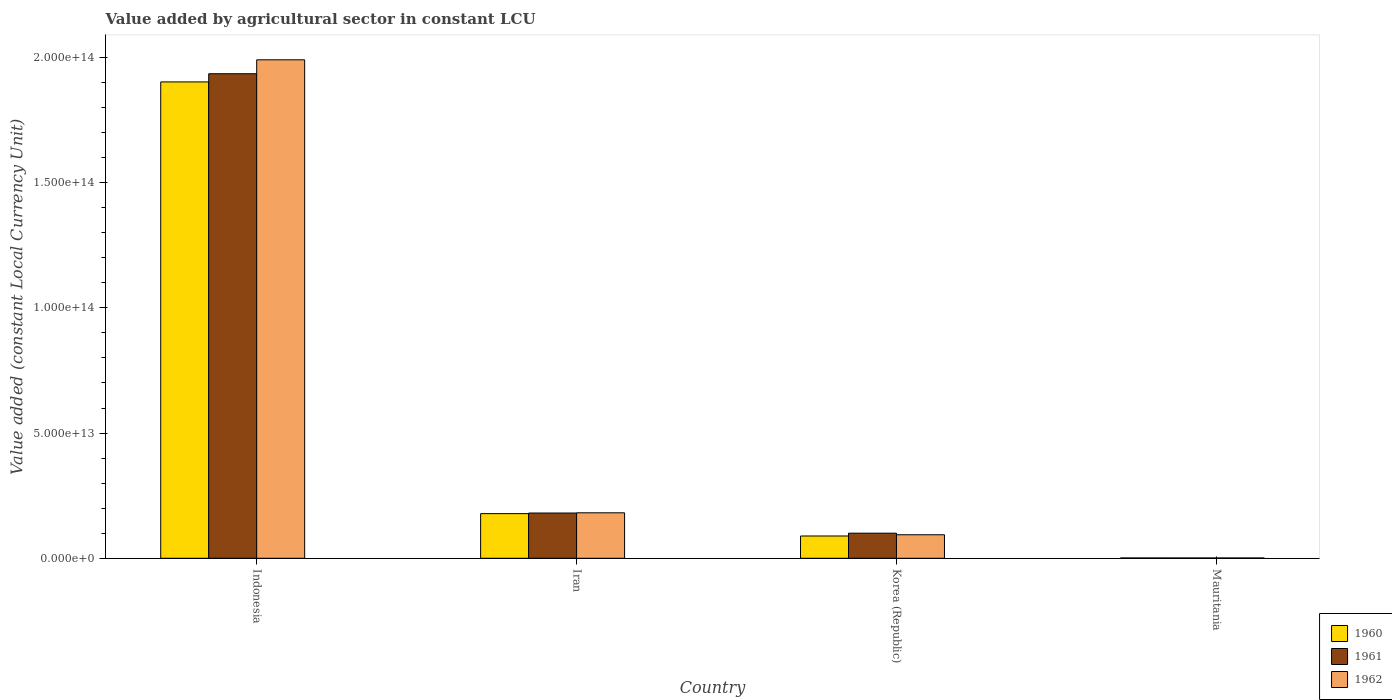How many different coloured bars are there?
Your answer should be very brief. 3. How many groups of bars are there?
Your response must be concise. 4. What is the label of the 4th group of bars from the left?
Your answer should be very brief. Mauritania. What is the value added by agricultural sector in 1961 in Indonesia?
Make the answer very short. 1.94e+14. Across all countries, what is the maximum value added by agricultural sector in 1962?
Keep it short and to the point. 1.99e+14. Across all countries, what is the minimum value added by agricultural sector in 1961?
Keep it short and to the point. 1.23e+11. In which country was the value added by agricultural sector in 1962 maximum?
Offer a very short reply. Indonesia. In which country was the value added by agricultural sector in 1960 minimum?
Offer a terse response. Mauritania. What is the total value added by agricultural sector in 1961 in the graph?
Your answer should be very brief. 2.22e+14. What is the difference between the value added by agricultural sector in 1961 in Iran and that in Mauritania?
Make the answer very short. 1.79e+13. What is the difference between the value added by agricultural sector in 1962 in Indonesia and the value added by agricultural sector in 1960 in Mauritania?
Your answer should be very brief. 1.99e+14. What is the average value added by agricultural sector in 1962 per country?
Offer a very short reply. 5.67e+13. What is the difference between the value added by agricultural sector of/in 1962 and value added by agricultural sector of/in 1960 in Iran?
Give a very brief answer. 3.32e+11. In how many countries, is the value added by agricultural sector in 1962 greater than 90000000000000 LCU?
Make the answer very short. 1. What is the ratio of the value added by agricultural sector in 1961 in Korea (Republic) to that in Mauritania?
Your response must be concise. 81.29. Is the value added by agricultural sector in 1961 in Indonesia less than that in Mauritania?
Make the answer very short. No. What is the difference between the highest and the second highest value added by agricultural sector in 1962?
Make the answer very short. -8.77e+12. What is the difference between the highest and the lowest value added by agricultural sector in 1960?
Your answer should be very brief. 1.90e+14. Is the sum of the value added by agricultural sector in 1960 in Korea (Republic) and Mauritania greater than the maximum value added by agricultural sector in 1962 across all countries?
Your response must be concise. No. What does the 2nd bar from the left in Iran represents?
Keep it short and to the point. 1961. How many bars are there?
Your answer should be compact. 12. Are all the bars in the graph horizontal?
Provide a succinct answer. No. How many countries are there in the graph?
Offer a very short reply. 4. What is the difference between two consecutive major ticks on the Y-axis?
Give a very brief answer. 5.00e+13. Does the graph contain any zero values?
Your answer should be compact. No. Does the graph contain grids?
Ensure brevity in your answer.  No. What is the title of the graph?
Provide a short and direct response. Value added by agricultural sector in constant LCU. What is the label or title of the X-axis?
Ensure brevity in your answer.  Country. What is the label or title of the Y-axis?
Your answer should be compact. Value added (constant Local Currency Unit). What is the Value added (constant Local Currency Unit) in 1960 in Indonesia?
Provide a succinct answer. 1.90e+14. What is the Value added (constant Local Currency Unit) in 1961 in Indonesia?
Keep it short and to the point. 1.94e+14. What is the Value added (constant Local Currency Unit) of 1962 in Indonesia?
Offer a very short reply. 1.99e+14. What is the Value added (constant Local Currency Unit) of 1960 in Iran?
Your answer should be very brief. 1.78e+13. What is the Value added (constant Local Currency Unit) of 1961 in Iran?
Your answer should be very brief. 1.81e+13. What is the Value added (constant Local Currency Unit) in 1962 in Iran?
Your response must be concise. 1.82e+13. What is the Value added (constant Local Currency Unit) in 1960 in Korea (Republic)?
Keep it short and to the point. 8.90e+12. What is the Value added (constant Local Currency Unit) in 1961 in Korea (Republic)?
Provide a short and direct response. 1.00e+13. What is the Value added (constant Local Currency Unit) of 1962 in Korea (Republic)?
Your answer should be very brief. 9.39e+12. What is the Value added (constant Local Currency Unit) in 1960 in Mauritania?
Your answer should be very brief. 1.27e+11. What is the Value added (constant Local Currency Unit) of 1961 in Mauritania?
Ensure brevity in your answer.  1.23e+11. What is the Value added (constant Local Currency Unit) of 1962 in Mauritania?
Keep it short and to the point. 1.20e+11. Across all countries, what is the maximum Value added (constant Local Currency Unit) in 1960?
Your answer should be very brief. 1.90e+14. Across all countries, what is the maximum Value added (constant Local Currency Unit) in 1961?
Make the answer very short. 1.94e+14. Across all countries, what is the maximum Value added (constant Local Currency Unit) of 1962?
Provide a succinct answer. 1.99e+14. Across all countries, what is the minimum Value added (constant Local Currency Unit) of 1960?
Ensure brevity in your answer.  1.27e+11. Across all countries, what is the minimum Value added (constant Local Currency Unit) of 1961?
Provide a succinct answer. 1.23e+11. Across all countries, what is the minimum Value added (constant Local Currency Unit) of 1962?
Ensure brevity in your answer.  1.20e+11. What is the total Value added (constant Local Currency Unit) in 1960 in the graph?
Offer a terse response. 2.17e+14. What is the total Value added (constant Local Currency Unit) in 1961 in the graph?
Your answer should be compact. 2.22e+14. What is the total Value added (constant Local Currency Unit) of 1962 in the graph?
Provide a short and direct response. 2.27e+14. What is the difference between the Value added (constant Local Currency Unit) of 1960 in Indonesia and that in Iran?
Your answer should be compact. 1.72e+14. What is the difference between the Value added (constant Local Currency Unit) in 1961 in Indonesia and that in Iran?
Provide a short and direct response. 1.75e+14. What is the difference between the Value added (constant Local Currency Unit) in 1962 in Indonesia and that in Iran?
Provide a succinct answer. 1.81e+14. What is the difference between the Value added (constant Local Currency Unit) in 1960 in Indonesia and that in Korea (Republic)?
Your answer should be very brief. 1.81e+14. What is the difference between the Value added (constant Local Currency Unit) of 1961 in Indonesia and that in Korea (Republic)?
Your answer should be very brief. 1.83e+14. What is the difference between the Value added (constant Local Currency Unit) in 1962 in Indonesia and that in Korea (Republic)?
Your answer should be very brief. 1.90e+14. What is the difference between the Value added (constant Local Currency Unit) of 1960 in Indonesia and that in Mauritania?
Your answer should be compact. 1.90e+14. What is the difference between the Value added (constant Local Currency Unit) of 1961 in Indonesia and that in Mauritania?
Your answer should be compact. 1.93e+14. What is the difference between the Value added (constant Local Currency Unit) in 1962 in Indonesia and that in Mauritania?
Your answer should be compact. 1.99e+14. What is the difference between the Value added (constant Local Currency Unit) of 1960 in Iran and that in Korea (Republic)?
Keep it short and to the point. 8.93e+12. What is the difference between the Value added (constant Local Currency Unit) in 1961 in Iran and that in Korea (Republic)?
Provide a succinct answer. 8.05e+12. What is the difference between the Value added (constant Local Currency Unit) in 1962 in Iran and that in Korea (Republic)?
Give a very brief answer. 8.77e+12. What is the difference between the Value added (constant Local Currency Unit) of 1960 in Iran and that in Mauritania?
Offer a terse response. 1.77e+13. What is the difference between the Value added (constant Local Currency Unit) in 1961 in Iran and that in Mauritania?
Offer a terse response. 1.79e+13. What is the difference between the Value added (constant Local Currency Unit) of 1962 in Iran and that in Mauritania?
Offer a very short reply. 1.80e+13. What is the difference between the Value added (constant Local Currency Unit) in 1960 in Korea (Republic) and that in Mauritania?
Your response must be concise. 8.77e+12. What is the difference between the Value added (constant Local Currency Unit) of 1961 in Korea (Republic) and that in Mauritania?
Your answer should be compact. 9.90e+12. What is the difference between the Value added (constant Local Currency Unit) of 1962 in Korea (Republic) and that in Mauritania?
Provide a short and direct response. 9.27e+12. What is the difference between the Value added (constant Local Currency Unit) of 1960 in Indonesia and the Value added (constant Local Currency Unit) of 1961 in Iran?
Your answer should be compact. 1.72e+14. What is the difference between the Value added (constant Local Currency Unit) in 1960 in Indonesia and the Value added (constant Local Currency Unit) in 1962 in Iran?
Your response must be concise. 1.72e+14. What is the difference between the Value added (constant Local Currency Unit) of 1961 in Indonesia and the Value added (constant Local Currency Unit) of 1962 in Iran?
Your answer should be very brief. 1.75e+14. What is the difference between the Value added (constant Local Currency Unit) of 1960 in Indonesia and the Value added (constant Local Currency Unit) of 1961 in Korea (Republic)?
Your answer should be very brief. 1.80e+14. What is the difference between the Value added (constant Local Currency Unit) of 1960 in Indonesia and the Value added (constant Local Currency Unit) of 1962 in Korea (Republic)?
Provide a short and direct response. 1.81e+14. What is the difference between the Value added (constant Local Currency Unit) of 1961 in Indonesia and the Value added (constant Local Currency Unit) of 1962 in Korea (Republic)?
Your response must be concise. 1.84e+14. What is the difference between the Value added (constant Local Currency Unit) in 1960 in Indonesia and the Value added (constant Local Currency Unit) in 1961 in Mauritania?
Provide a succinct answer. 1.90e+14. What is the difference between the Value added (constant Local Currency Unit) in 1960 in Indonesia and the Value added (constant Local Currency Unit) in 1962 in Mauritania?
Your answer should be compact. 1.90e+14. What is the difference between the Value added (constant Local Currency Unit) of 1961 in Indonesia and the Value added (constant Local Currency Unit) of 1962 in Mauritania?
Your answer should be compact. 1.93e+14. What is the difference between the Value added (constant Local Currency Unit) of 1960 in Iran and the Value added (constant Local Currency Unit) of 1961 in Korea (Republic)?
Ensure brevity in your answer.  7.81e+12. What is the difference between the Value added (constant Local Currency Unit) of 1960 in Iran and the Value added (constant Local Currency Unit) of 1962 in Korea (Republic)?
Ensure brevity in your answer.  8.44e+12. What is the difference between the Value added (constant Local Currency Unit) of 1961 in Iran and the Value added (constant Local Currency Unit) of 1962 in Korea (Republic)?
Ensure brevity in your answer.  8.68e+12. What is the difference between the Value added (constant Local Currency Unit) of 1960 in Iran and the Value added (constant Local Currency Unit) of 1961 in Mauritania?
Give a very brief answer. 1.77e+13. What is the difference between the Value added (constant Local Currency Unit) in 1960 in Iran and the Value added (constant Local Currency Unit) in 1962 in Mauritania?
Keep it short and to the point. 1.77e+13. What is the difference between the Value added (constant Local Currency Unit) of 1961 in Iran and the Value added (constant Local Currency Unit) of 1962 in Mauritania?
Ensure brevity in your answer.  1.80e+13. What is the difference between the Value added (constant Local Currency Unit) of 1960 in Korea (Republic) and the Value added (constant Local Currency Unit) of 1961 in Mauritania?
Your answer should be very brief. 8.77e+12. What is the difference between the Value added (constant Local Currency Unit) in 1960 in Korea (Republic) and the Value added (constant Local Currency Unit) in 1962 in Mauritania?
Provide a short and direct response. 8.78e+12. What is the difference between the Value added (constant Local Currency Unit) of 1961 in Korea (Republic) and the Value added (constant Local Currency Unit) of 1962 in Mauritania?
Offer a terse response. 9.90e+12. What is the average Value added (constant Local Currency Unit) in 1960 per country?
Your response must be concise. 5.43e+13. What is the average Value added (constant Local Currency Unit) in 1961 per country?
Give a very brief answer. 5.54e+13. What is the average Value added (constant Local Currency Unit) in 1962 per country?
Provide a short and direct response. 5.67e+13. What is the difference between the Value added (constant Local Currency Unit) of 1960 and Value added (constant Local Currency Unit) of 1961 in Indonesia?
Your answer should be compact. -3.27e+12. What is the difference between the Value added (constant Local Currency Unit) in 1960 and Value added (constant Local Currency Unit) in 1962 in Indonesia?
Provide a succinct answer. -8.83e+12. What is the difference between the Value added (constant Local Currency Unit) in 1961 and Value added (constant Local Currency Unit) in 1962 in Indonesia?
Provide a succinct answer. -5.56e+12. What is the difference between the Value added (constant Local Currency Unit) of 1960 and Value added (constant Local Currency Unit) of 1961 in Iran?
Your answer should be very brief. -2.42e+11. What is the difference between the Value added (constant Local Currency Unit) of 1960 and Value added (constant Local Currency Unit) of 1962 in Iran?
Offer a terse response. -3.32e+11. What is the difference between the Value added (constant Local Currency Unit) of 1961 and Value added (constant Local Currency Unit) of 1962 in Iran?
Provide a short and direct response. -8.95e+1. What is the difference between the Value added (constant Local Currency Unit) of 1960 and Value added (constant Local Currency Unit) of 1961 in Korea (Republic)?
Keep it short and to the point. -1.12e+12. What is the difference between the Value added (constant Local Currency Unit) in 1960 and Value added (constant Local Currency Unit) in 1962 in Korea (Republic)?
Keep it short and to the point. -4.93e+11. What is the difference between the Value added (constant Local Currency Unit) in 1961 and Value added (constant Local Currency Unit) in 1962 in Korea (Republic)?
Make the answer very short. 6.31e+11. What is the difference between the Value added (constant Local Currency Unit) in 1960 and Value added (constant Local Currency Unit) in 1961 in Mauritania?
Your answer should be compact. 4.01e+09. What is the difference between the Value added (constant Local Currency Unit) of 1960 and Value added (constant Local Currency Unit) of 1962 in Mauritania?
Provide a succinct answer. 7.67e+09. What is the difference between the Value added (constant Local Currency Unit) in 1961 and Value added (constant Local Currency Unit) in 1962 in Mauritania?
Ensure brevity in your answer.  3.65e+09. What is the ratio of the Value added (constant Local Currency Unit) in 1960 in Indonesia to that in Iran?
Provide a short and direct response. 10.67. What is the ratio of the Value added (constant Local Currency Unit) in 1961 in Indonesia to that in Iran?
Provide a succinct answer. 10.71. What is the ratio of the Value added (constant Local Currency Unit) of 1962 in Indonesia to that in Iran?
Keep it short and to the point. 10.96. What is the ratio of the Value added (constant Local Currency Unit) in 1960 in Indonesia to that in Korea (Republic)?
Give a very brief answer. 21.38. What is the ratio of the Value added (constant Local Currency Unit) of 1961 in Indonesia to that in Korea (Republic)?
Give a very brief answer. 19.31. What is the ratio of the Value added (constant Local Currency Unit) in 1962 in Indonesia to that in Korea (Republic)?
Your response must be concise. 21.2. What is the ratio of the Value added (constant Local Currency Unit) in 1960 in Indonesia to that in Mauritania?
Offer a very short reply. 1494.5. What is the ratio of the Value added (constant Local Currency Unit) of 1961 in Indonesia to that in Mauritania?
Provide a short and direct response. 1569.7. What is the ratio of the Value added (constant Local Currency Unit) of 1962 in Indonesia to that in Mauritania?
Your answer should be very brief. 1664.14. What is the ratio of the Value added (constant Local Currency Unit) of 1960 in Iran to that in Korea (Republic)?
Ensure brevity in your answer.  2. What is the ratio of the Value added (constant Local Currency Unit) of 1961 in Iran to that in Korea (Republic)?
Offer a terse response. 1.8. What is the ratio of the Value added (constant Local Currency Unit) in 1962 in Iran to that in Korea (Republic)?
Keep it short and to the point. 1.93. What is the ratio of the Value added (constant Local Currency Unit) of 1960 in Iran to that in Mauritania?
Provide a short and direct response. 140.05. What is the ratio of the Value added (constant Local Currency Unit) of 1961 in Iran to that in Mauritania?
Provide a short and direct response. 146.57. What is the ratio of the Value added (constant Local Currency Unit) of 1962 in Iran to that in Mauritania?
Offer a terse response. 151.8. What is the ratio of the Value added (constant Local Currency Unit) of 1960 in Korea (Republic) to that in Mauritania?
Give a very brief answer. 69.9. What is the ratio of the Value added (constant Local Currency Unit) of 1961 in Korea (Republic) to that in Mauritania?
Your answer should be compact. 81.29. What is the ratio of the Value added (constant Local Currency Unit) in 1962 in Korea (Republic) to that in Mauritania?
Your answer should be compact. 78.51. What is the difference between the highest and the second highest Value added (constant Local Currency Unit) in 1960?
Offer a very short reply. 1.72e+14. What is the difference between the highest and the second highest Value added (constant Local Currency Unit) in 1961?
Keep it short and to the point. 1.75e+14. What is the difference between the highest and the second highest Value added (constant Local Currency Unit) in 1962?
Give a very brief answer. 1.81e+14. What is the difference between the highest and the lowest Value added (constant Local Currency Unit) of 1960?
Make the answer very short. 1.90e+14. What is the difference between the highest and the lowest Value added (constant Local Currency Unit) of 1961?
Give a very brief answer. 1.93e+14. What is the difference between the highest and the lowest Value added (constant Local Currency Unit) in 1962?
Your answer should be compact. 1.99e+14. 